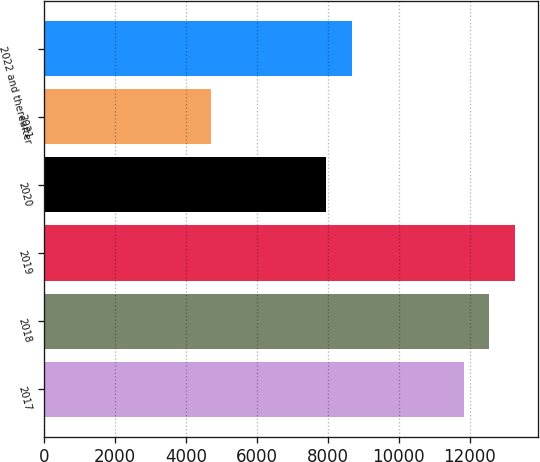Convert chart. <chart><loc_0><loc_0><loc_500><loc_500><bar_chart><fcel>2017<fcel>2018<fcel>2019<fcel>2020<fcel>2021<fcel>2022 and thereafter<nl><fcel>11845<fcel>12557.4<fcel>13269.8<fcel>7963<fcel>4721<fcel>8675.4<nl></chart> 